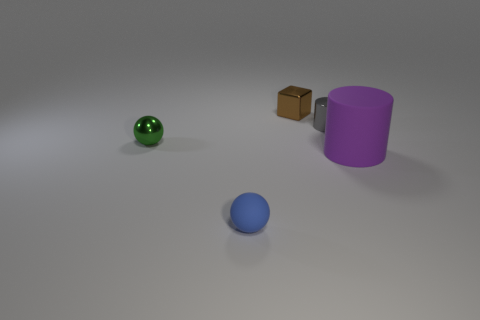How many things are either tiny gray metallic objects or tiny balls that are in front of the big purple rubber object?
Your response must be concise. 2. What number of blue things are matte objects or tiny objects?
Your answer should be very brief. 1. How many other objects are the same size as the brown cube?
Offer a terse response. 3. What number of tiny objects are metallic blocks or balls?
Your answer should be very brief. 3. There is a blue rubber ball; does it have the same size as the object left of the small matte sphere?
Ensure brevity in your answer.  Yes. How many other things are the same shape as the purple rubber object?
Your answer should be very brief. 1. There is a green object that is the same material as the gray cylinder; what shape is it?
Keep it short and to the point. Sphere. Are there any tiny blue rubber balls?
Keep it short and to the point. Yes. Is the number of small metal blocks behind the brown metal thing less than the number of small green balls on the left side of the large purple cylinder?
Your answer should be very brief. Yes. The shiny object that is right of the tiny brown shiny object has what shape?
Offer a terse response. Cylinder. 